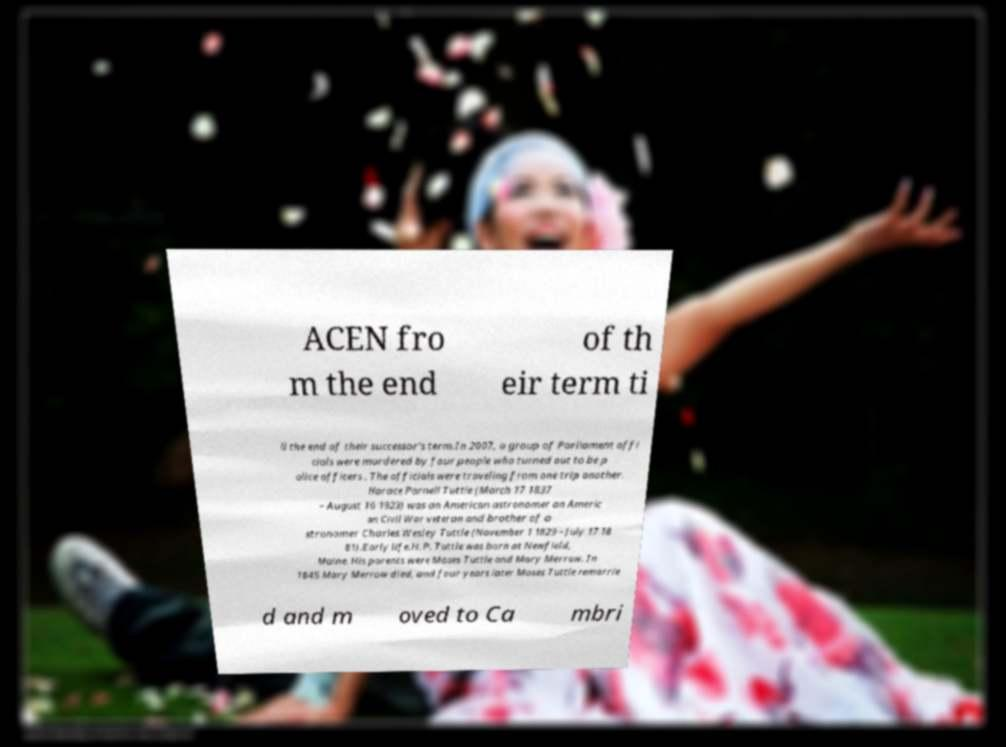Can you read and provide the text displayed in the image?This photo seems to have some interesting text. Can you extract and type it out for me? ACEN fro m the end of th eir term ti ll the end of their successor's term.In 2007, a group of Parliament offi cials were murdered by four people who turned out to be p olice officers . The officials were traveling from one trip another. Horace Parnell Tuttle (March 17 1837 – August 16 1923) was an American astronomer an Americ an Civil War veteran and brother of a stronomer Charles Wesley Tuttle (November 1 1829 – July 17 18 81).Early life.H. P. Tuttle was born at Newfield, Maine. His parents were Moses Tuttle and Mary Merrow. In 1845 Mary Merrow died, and four years later Moses Tuttle remarrie d and m oved to Ca mbri 